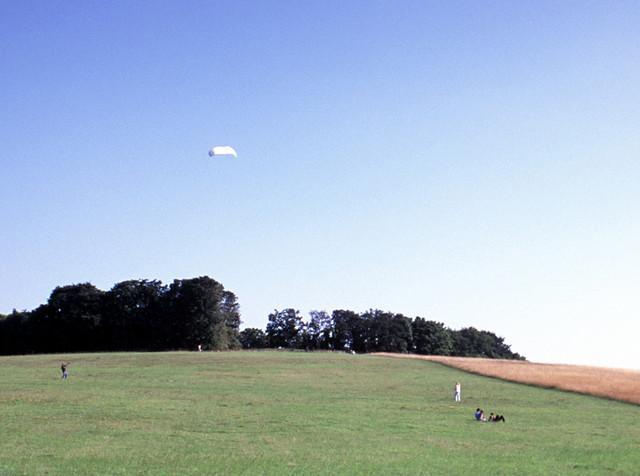What type of location is being visited?
Answer the question by selecting the correct answer among the 4 following choices and explain your choice with a short sentence. The answer should be formatted with the following format: `Answer: choice
Rationale: rationale.`
Options: Forest, swamp, ocean, field. Answer: field.
Rationale: A field with grass is shown. 